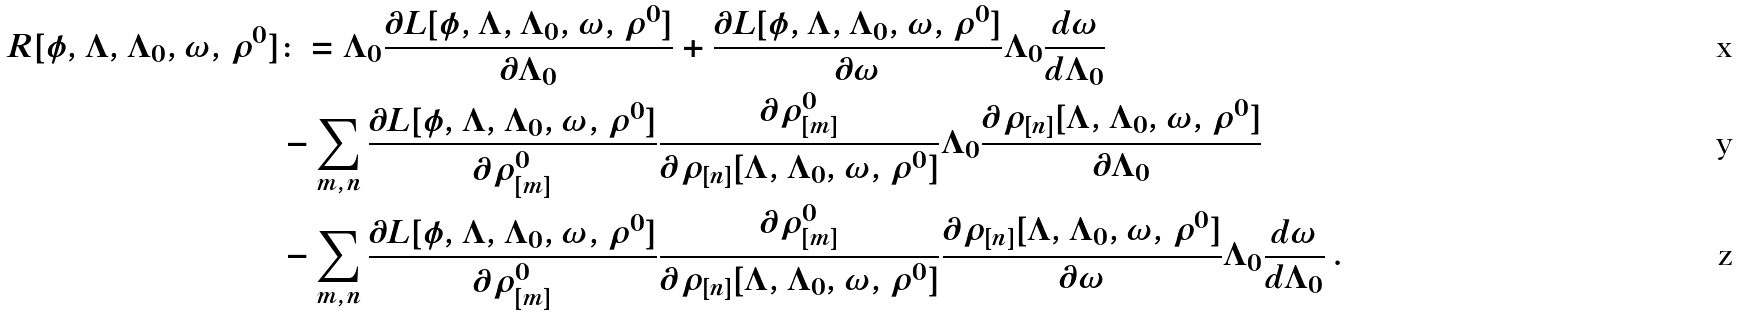Convert formula to latex. <formula><loc_0><loc_0><loc_500><loc_500>R [ \phi , \Lambda , \Lambda _ { 0 } , \omega , \rho ^ { 0 } ] & \colon = \Lambda _ { 0 } \frac { \partial L [ \phi , \Lambda , \Lambda _ { 0 } , \omega , \rho ^ { 0 } ] } { \partial \Lambda _ { 0 } } + \frac { \partial L [ \phi , \Lambda , \Lambda _ { 0 } , \omega , \rho ^ { 0 } ] } { \partial \omega } \Lambda _ { 0 } \frac { d \omega } { d \Lambda _ { 0 } } \\ & - \sum _ { m , n } \frac { \partial L [ \phi , \Lambda , \Lambda _ { 0 } , \omega , \rho ^ { 0 } ] } { \partial \rho _ { [ m ] } ^ { 0 } } \frac { \partial \rho _ { [ m ] } ^ { 0 } } { \partial \rho _ { [ n ] } [ \Lambda , \Lambda _ { 0 } , \omega , \rho ^ { 0 } ] } \Lambda _ { 0 } \frac { \partial \rho _ { [ n ] } [ \Lambda , \Lambda _ { 0 } , \omega , \rho ^ { 0 } ] } { \partial \Lambda _ { 0 } } \\ & - \sum _ { m , n } \frac { \partial L [ \phi , \Lambda , \Lambda _ { 0 } , \omega , \rho ^ { 0 } ] } { \partial \rho _ { [ m ] } ^ { 0 } } \frac { \partial \rho _ { [ m ] } ^ { 0 } } { \partial \rho _ { [ n ] } [ \Lambda , \Lambda _ { 0 } , \omega , \rho ^ { 0 } ] } \frac { \partial \rho _ { [ n ] } [ \Lambda , \Lambda _ { 0 } , \omega , \rho ^ { 0 } ] } { \partial \omega } \Lambda _ { 0 } \frac { d \omega } { d \Lambda _ { 0 } } \, .</formula> 